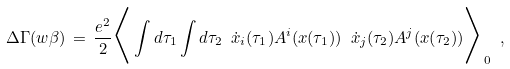<formula> <loc_0><loc_0><loc_500><loc_500>\Delta \Gamma ( w \beta ) \, = \, \frac { e ^ { 2 } } { 2 } \Big < \int d \tau _ { 1 } \int d \tau _ { 2 } \ { \dot { x } } _ { i } ( \tau _ { 1 } ) A ^ { i } ( x ( \tau _ { 1 } ) ) \ { \dot { x } } _ { j } ( \tau _ { 2 } ) A ^ { j } ( x ( \tau _ { 2 } ) ) \Big > _ { 0 } \ ,</formula> 